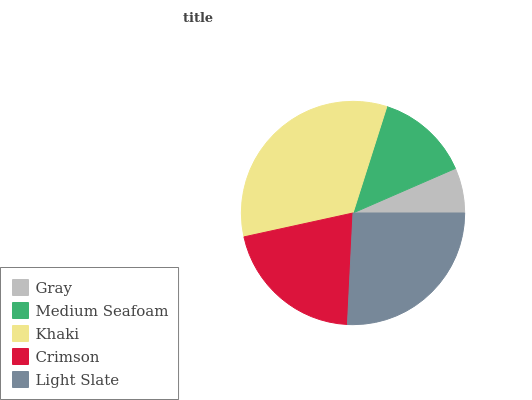Is Gray the minimum?
Answer yes or no. Yes. Is Khaki the maximum?
Answer yes or no. Yes. Is Medium Seafoam the minimum?
Answer yes or no. No. Is Medium Seafoam the maximum?
Answer yes or no. No. Is Medium Seafoam greater than Gray?
Answer yes or no. Yes. Is Gray less than Medium Seafoam?
Answer yes or no. Yes. Is Gray greater than Medium Seafoam?
Answer yes or no. No. Is Medium Seafoam less than Gray?
Answer yes or no. No. Is Crimson the high median?
Answer yes or no. Yes. Is Crimson the low median?
Answer yes or no. Yes. Is Khaki the high median?
Answer yes or no. No. Is Khaki the low median?
Answer yes or no. No. 